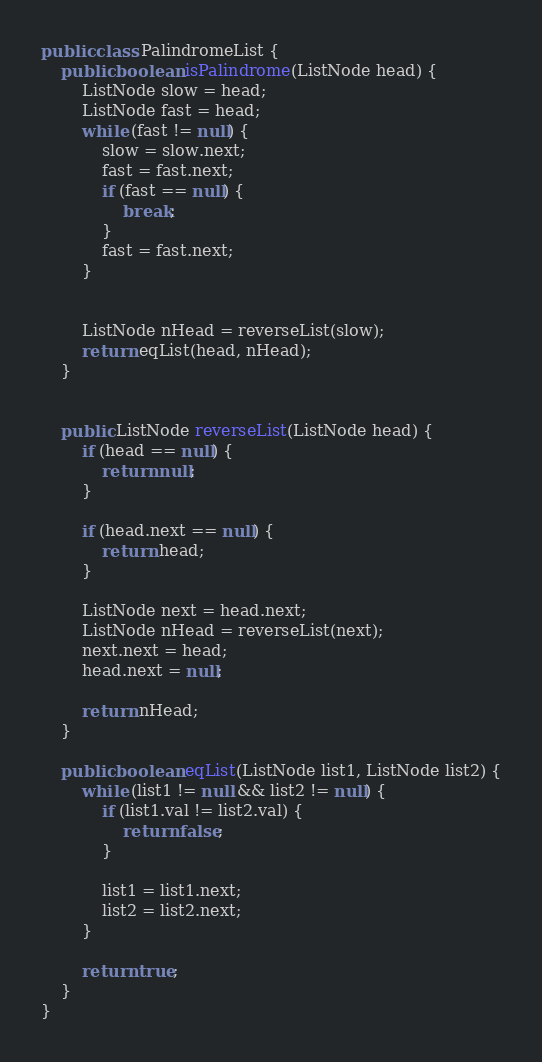Convert code to text. <code><loc_0><loc_0><loc_500><loc_500><_Java_>public class PalindromeList {
    public boolean isPalindrome(ListNode head) {
        ListNode slow = head;
        ListNode fast = head;
        while (fast != null) {
            slow = slow.next;
            fast = fast.next;
            if (fast == null) {
                break;
            }
            fast = fast.next;
        }


        ListNode nHead = reverseList(slow);
        return eqList(head, nHead);
    }


    public ListNode reverseList(ListNode head) {
        if (head == null) {
            return null;
        }

        if (head.next == null) {
            return head;
        }

        ListNode next = head.next;
        ListNode nHead = reverseList(next);
        next.next = head;
        head.next = null;

        return nHead;
    }

    public boolean eqList(ListNode list1, ListNode list2) {
        while (list1 != null && list2 != null) {
            if (list1.val != list2.val) {
                return false;
            }

            list1 = list1.next;
            list2 = list2.next;
        }

        return true;
    }
}
</code> 